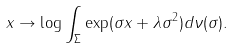<formula> <loc_0><loc_0><loc_500><loc_500>x \to \log \int _ { \Sigma } \exp ( \sigma x + \lambda \sigma ^ { 2 } ) d \nu ( \sigma ) .</formula> 